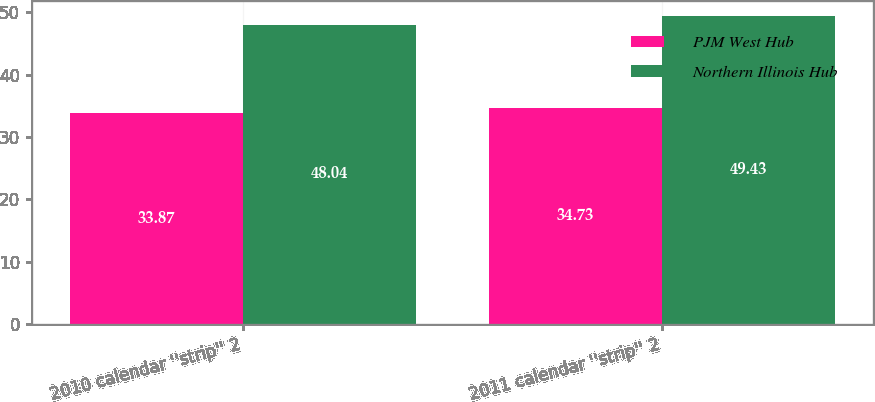<chart> <loc_0><loc_0><loc_500><loc_500><stacked_bar_chart><ecel><fcel>2010 calendar ''strip'' 2<fcel>2011 calendar ''strip'' 2<nl><fcel>PJM West Hub<fcel>33.87<fcel>34.73<nl><fcel>Northern Illinois Hub<fcel>48.04<fcel>49.43<nl></chart> 